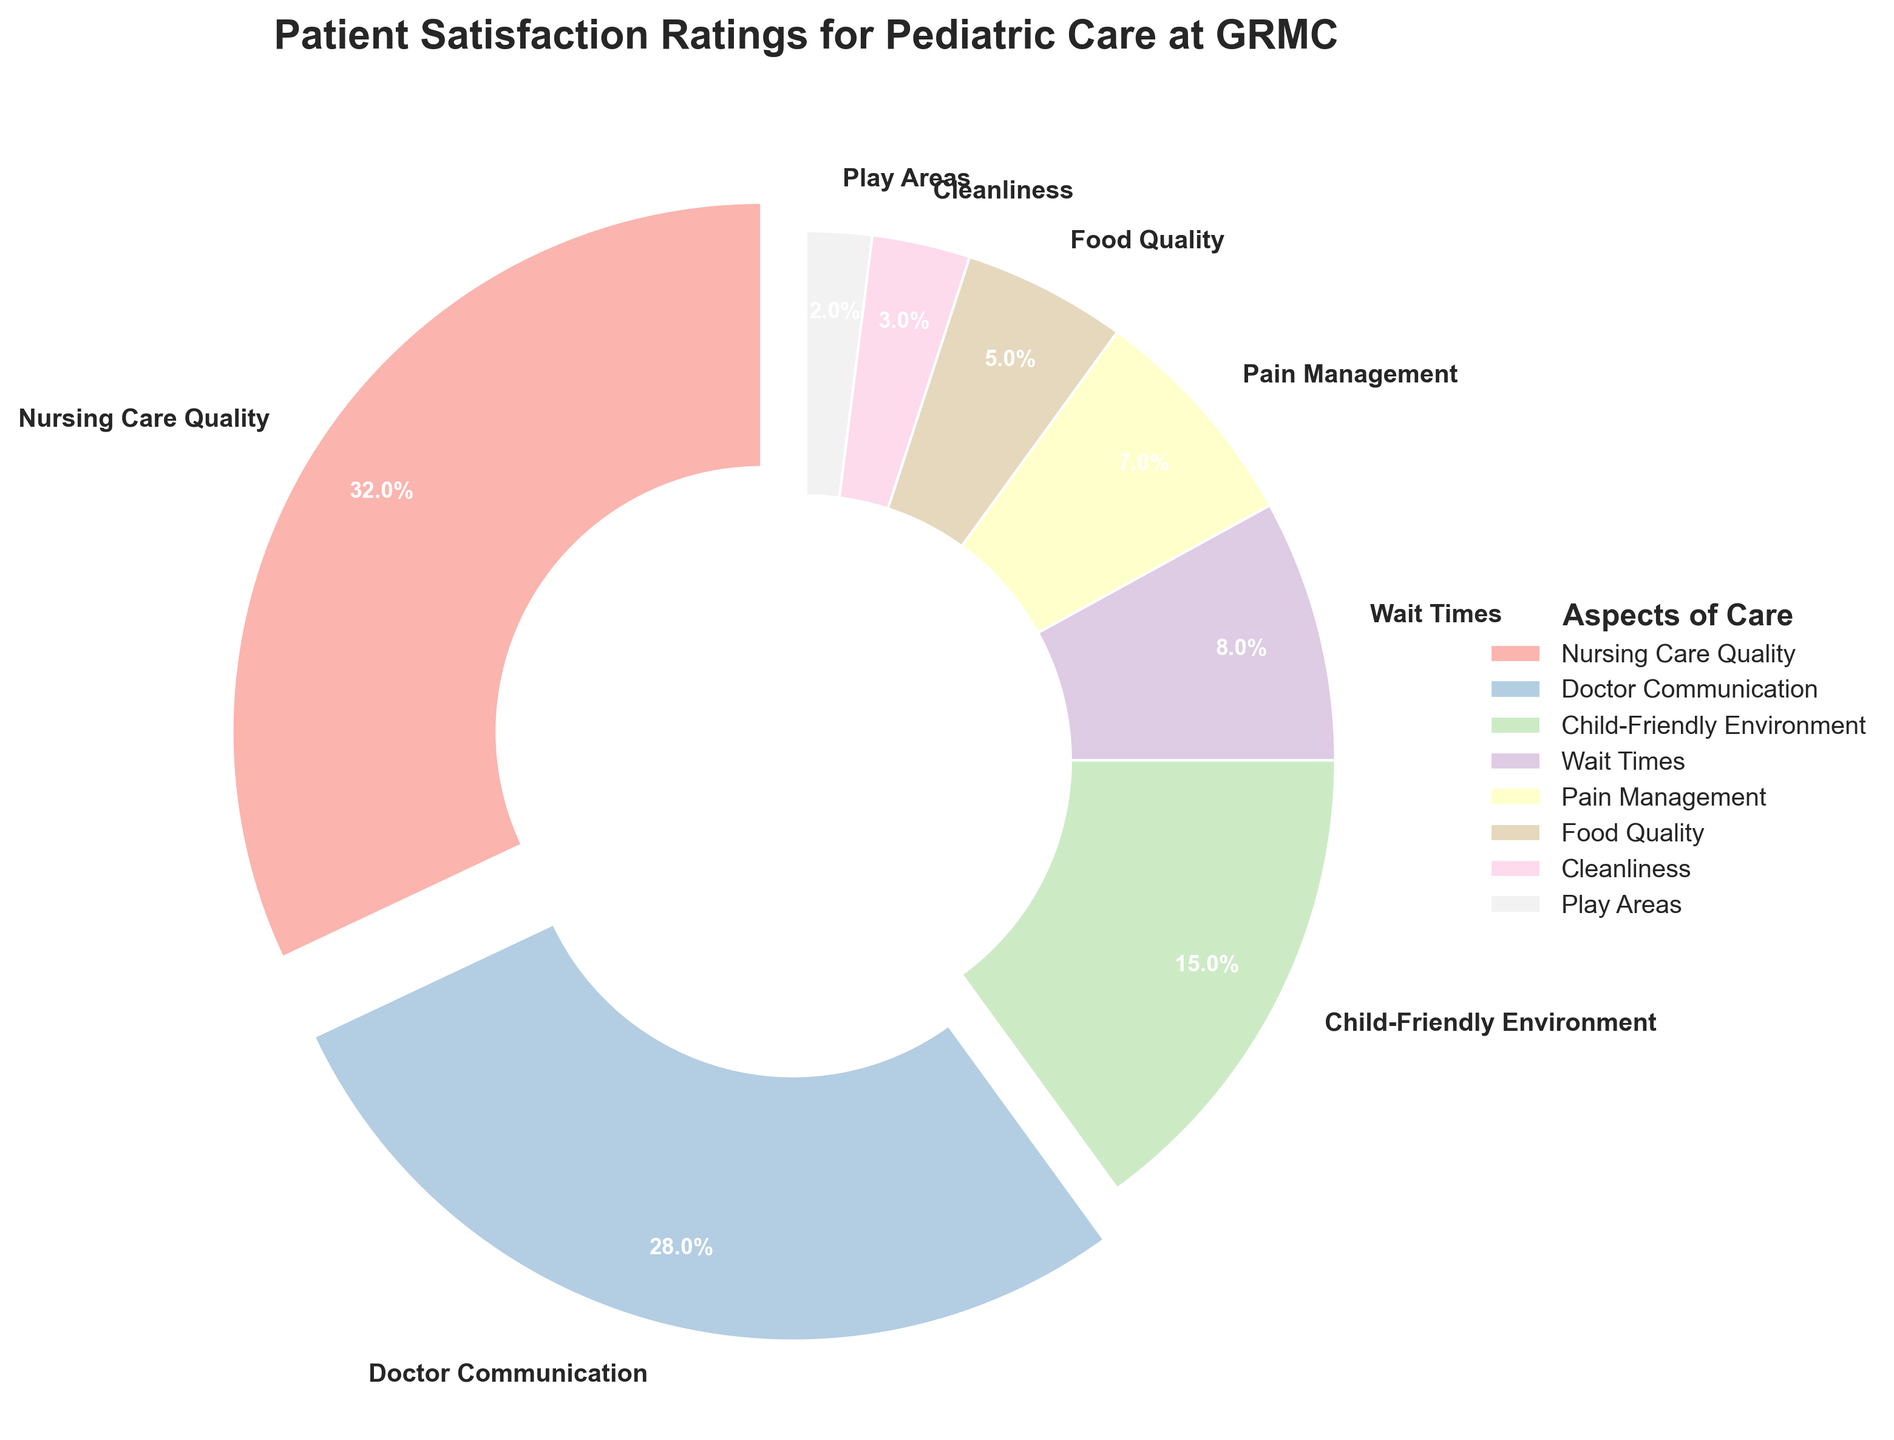What percentage of patients are satisfied with Nursing Care Quality? The wedge labeled "Nursing Care Quality" shows a percentage of satisfaction at 32% in the pie chart.
Answer: 32% How does the satisfaction with Doctor Communication compare to Pain Management? The pie chart indicates that satisfaction with Doctor Communication is 28%, while satisfaction with Pain Management is 7%. Doctor Communication satisfaction is significantly higher than Pain Management.
Answer: Doctor Communication is higher Which aspect has the lowest patient satisfaction rating? According to the pie chart, the aspect with the lowest satisfaction rating is "Play Areas," with a satisfaction percentage of 2%.
Answer: Play Areas What is the combined percentage of satisfaction for Child-Friendly Environment and Cleanliness? The pie chart shows that the satisfaction percentage for Child-Friendly Environment is 15% and for Cleanliness it is 3%. Combining these percentages: 15% + 3% = 18%.
Answer: 18% If you add the satisfaction percentages for Nursing Care Quality and Doctor Communication, does it exceed 50%? The satisfaction percentage for Nursing Care Quality is 32% and for Doctor Communication is 28%. Adding these percentages: 32% + 28% = 60%. Since 60% is greater than 50%, the combined satisfaction does exceed 50%.
Answer: Yes Is the satisfaction with Food Quality higher or lower than Child-Friendly Environment? The pie chart shows the satisfaction with Food Quality at 5% and with Child-Friendly Environment at 15%. The satisfaction with Food Quality is lower.
Answer: Lower Which aspect of pediatric care has a satisfaction rating closest to the average satisfaction rating of all aspects? First, calculate the average satisfaction rating: (32 + 28 + 15 + 8 + 7 + 5 + 3 + 2) / 8 = 100 / 8 = 12.5%. The aspect closest to this average is "Child-Friendly Environment" with a satisfaction rating of 15%.
Answer: Child-Friendly Environment How far above or below the average satisfaction rating is the Wait Times aspect? Calculate the average satisfaction rating: (32 + 28 + 15 + 8 + 7 + 5 + 3 + 2) / 8 = 12.5%. The satisfaction rating for Wait Times is 8%. Find the difference: 12.5% - 8% = 4.5%. The Wait Times satisfaction is 4.5% below the average.
Answer: 4.5% below What are the top three aspects with the highest patient satisfaction ratings? Referring to the pie chart, the top three aspects with the highest satisfaction ratings are "Nursing Care Quality" at 32%, "Doctor Communication" at 28%, and "Child-Friendly Environment" at 15%.
Answer: Nursing Care Quality, Doctor Communication, Child-Friendly Environment Is the satisfaction with Cleanliness less than one-quarter of the combined satisfaction with Nursing Care Quality and Doctor Communication? The satisfaction percentage for Nursing Care Quality is 32% and for Doctor Communication is 28%. Combined, they are 32% + 28% = 60%. One-quarter of this combined satisfaction is 60% / 4 = 15%. The satisfaction with Cleanliness is 3%, which is less than 15%.
Answer: Yes 